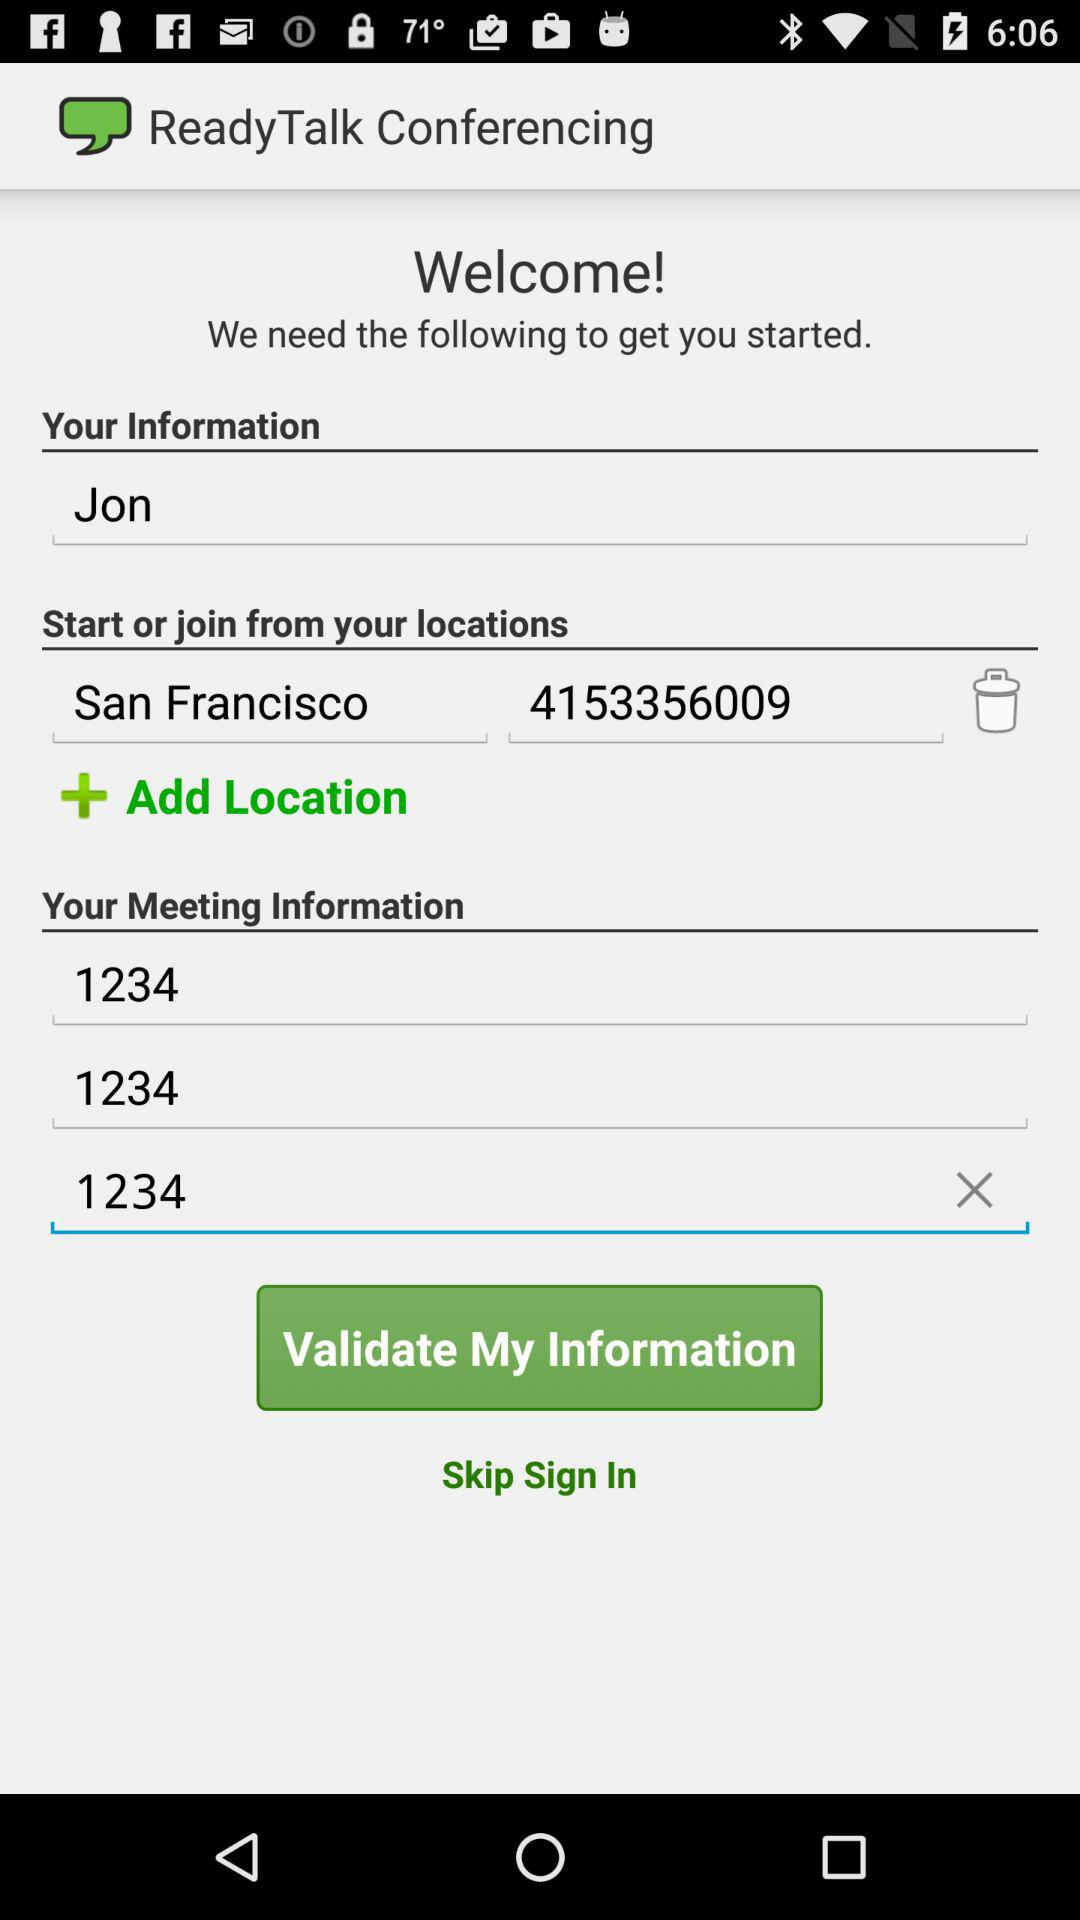What is the name of the user? The name of the user is Jon. 